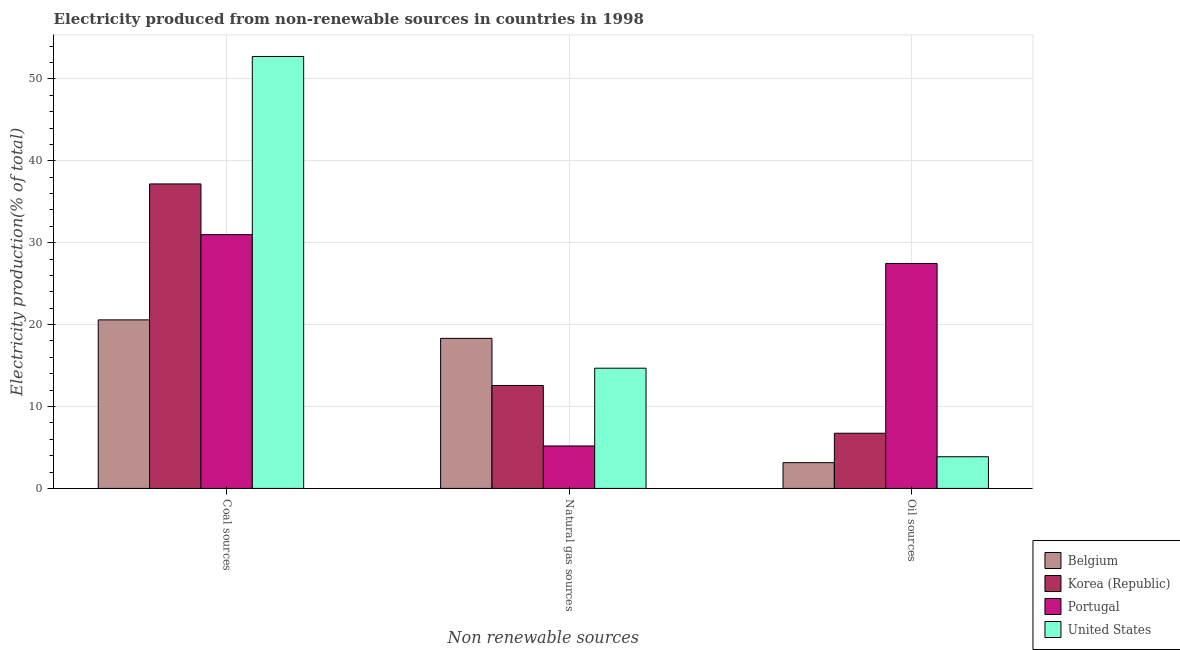How many different coloured bars are there?
Make the answer very short. 4. Are the number of bars on each tick of the X-axis equal?
Offer a very short reply. Yes. What is the label of the 3rd group of bars from the left?
Your answer should be compact. Oil sources. What is the percentage of electricity produced by coal in Belgium?
Ensure brevity in your answer.  20.58. Across all countries, what is the maximum percentage of electricity produced by oil sources?
Give a very brief answer. 27.46. Across all countries, what is the minimum percentage of electricity produced by coal?
Offer a very short reply. 20.58. In which country was the percentage of electricity produced by natural gas minimum?
Make the answer very short. Portugal. What is the total percentage of electricity produced by oil sources in the graph?
Give a very brief answer. 41.21. What is the difference between the percentage of electricity produced by oil sources in Belgium and that in Korea (Republic)?
Ensure brevity in your answer.  -3.59. What is the difference between the percentage of electricity produced by oil sources in Portugal and the percentage of electricity produced by coal in United States?
Keep it short and to the point. -25.27. What is the average percentage of electricity produced by oil sources per country?
Your answer should be compact. 10.3. What is the difference between the percentage of electricity produced by oil sources and percentage of electricity produced by coal in United States?
Ensure brevity in your answer.  -48.87. What is the ratio of the percentage of electricity produced by natural gas in United States to that in Belgium?
Offer a terse response. 0.8. Is the percentage of electricity produced by coal in Portugal less than that in United States?
Provide a short and direct response. Yes. Is the difference between the percentage of electricity produced by coal in Portugal and Korea (Republic) greater than the difference between the percentage of electricity produced by oil sources in Portugal and Korea (Republic)?
Give a very brief answer. No. What is the difference between the highest and the second highest percentage of electricity produced by coal?
Provide a short and direct response. 15.56. What is the difference between the highest and the lowest percentage of electricity produced by coal?
Make the answer very short. 32.16. In how many countries, is the percentage of electricity produced by natural gas greater than the average percentage of electricity produced by natural gas taken over all countries?
Provide a short and direct response. 2. What does the 2nd bar from the left in Natural gas sources represents?
Offer a terse response. Korea (Republic). Is it the case that in every country, the sum of the percentage of electricity produced by coal and percentage of electricity produced by natural gas is greater than the percentage of electricity produced by oil sources?
Provide a short and direct response. Yes. Does the graph contain any zero values?
Provide a short and direct response. No. Does the graph contain grids?
Make the answer very short. Yes. Where does the legend appear in the graph?
Your answer should be compact. Bottom right. How many legend labels are there?
Offer a very short reply. 4. What is the title of the graph?
Make the answer very short. Electricity produced from non-renewable sources in countries in 1998. What is the label or title of the X-axis?
Provide a succinct answer. Non renewable sources. What is the label or title of the Y-axis?
Keep it short and to the point. Electricity production(% of total). What is the Electricity production(% of total) in Belgium in Coal sources?
Your response must be concise. 20.58. What is the Electricity production(% of total) in Korea (Republic) in Coal sources?
Provide a short and direct response. 37.17. What is the Electricity production(% of total) of Portugal in Coal sources?
Offer a terse response. 30.98. What is the Electricity production(% of total) of United States in Coal sources?
Ensure brevity in your answer.  52.74. What is the Electricity production(% of total) of Belgium in Natural gas sources?
Your response must be concise. 18.32. What is the Electricity production(% of total) of Korea (Republic) in Natural gas sources?
Provide a succinct answer. 12.57. What is the Electricity production(% of total) of Portugal in Natural gas sources?
Your response must be concise. 5.19. What is the Electricity production(% of total) of United States in Natural gas sources?
Provide a succinct answer. 14.68. What is the Electricity production(% of total) in Belgium in Oil sources?
Make the answer very short. 3.14. What is the Electricity production(% of total) of Korea (Republic) in Oil sources?
Provide a short and direct response. 6.74. What is the Electricity production(% of total) of Portugal in Oil sources?
Ensure brevity in your answer.  27.46. What is the Electricity production(% of total) of United States in Oil sources?
Offer a terse response. 3.87. Across all Non renewable sources, what is the maximum Electricity production(% of total) of Belgium?
Give a very brief answer. 20.58. Across all Non renewable sources, what is the maximum Electricity production(% of total) in Korea (Republic)?
Make the answer very short. 37.17. Across all Non renewable sources, what is the maximum Electricity production(% of total) of Portugal?
Your response must be concise. 30.98. Across all Non renewable sources, what is the maximum Electricity production(% of total) in United States?
Provide a short and direct response. 52.74. Across all Non renewable sources, what is the minimum Electricity production(% of total) in Belgium?
Ensure brevity in your answer.  3.14. Across all Non renewable sources, what is the minimum Electricity production(% of total) in Korea (Republic)?
Keep it short and to the point. 6.74. Across all Non renewable sources, what is the minimum Electricity production(% of total) in Portugal?
Provide a succinct answer. 5.19. Across all Non renewable sources, what is the minimum Electricity production(% of total) in United States?
Your response must be concise. 3.87. What is the total Electricity production(% of total) in Belgium in the graph?
Provide a succinct answer. 42.04. What is the total Electricity production(% of total) in Korea (Republic) in the graph?
Give a very brief answer. 56.48. What is the total Electricity production(% of total) of Portugal in the graph?
Offer a terse response. 63.63. What is the total Electricity production(% of total) of United States in the graph?
Your response must be concise. 71.28. What is the difference between the Electricity production(% of total) in Belgium in Coal sources and that in Natural gas sources?
Make the answer very short. 2.26. What is the difference between the Electricity production(% of total) of Korea (Republic) in Coal sources and that in Natural gas sources?
Your answer should be compact. 24.61. What is the difference between the Electricity production(% of total) in Portugal in Coal sources and that in Natural gas sources?
Your response must be concise. 25.79. What is the difference between the Electricity production(% of total) in United States in Coal sources and that in Natural gas sources?
Provide a short and direct response. 38.06. What is the difference between the Electricity production(% of total) in Belgium in Coal sources and that in Oil sources?
Make the answer very short. 17.44. What is the difference between the Electricity production(% of total) in Korea (Republic) in Coal sources and that in Oil sources?
Ensure brevity in your answer.  30.44. What is the difference between the Electricity production(% of total) of Portugal in Coal sources and that in Oil sources?
Your answer should be compact. 3.52. What is the difference between the Electricity production(% of total) in United States in Coal sources and that in Oil sources?
Provide a short and direct response. 48.87. What is the difference between the Electricity production(% of total) in Belgium in Natural gas sources and that in Oil sources?
Make the answer very short. 15.18. What is the difference between the Electricity production(% of total) of Korea (Republic) in Natural gas sources and that in Oil sources?
Keep it short and to the point. 5.83. What is the difference between the Electricity production(% of total) in Portugal in Natural gas sources and that in Oil sources?
Give a very brief answer. -22.28. What is the difference between the Electricity production(% of total) of United States in Natural gas sources and that in Oil sources?
Ensure brevity in your answer.  10.81. What is the difference between the Electricity production(% of total) in Belgium in Coal sources and the Electricity production(% of total) in Korea (Republic) in Natural gas sources?
Provide a succinct answer. 8.01. What is the difference between the Electricity production(% of total) in Belgium in Coal sources and the Electricity production(% of total) in Portugal in Natural gas sources?
Give a very brief answer. 15.39. What is the difference between the Electricity production(% of total) in Belgium in Coal sources and the Electricity production(% of total) in United States in Natural gas sources?
Your answer should be compact. 5.9. What is the difference between the Electricity production(% of total) of Korea (Republic) in Coal sources and the Electricity production(% of total) of Portugal in Natural gas sources?
Offer a terse response. 31.99. What is the difference between the Electricity production(% of total) of Korea (Republic) in Coal sources and the Electricity production(% of total) of United States in Natural gas sources?
Provide a succinct answer. 22.5. What is the difference between the Electricity production(% of total) of Portugal in Coal sources and the Electricity production(% of total) of United States in Natural gas sources?
Your answer should be compact. 16.3. What is the difference between the Electricity production(% of total) of Belgium in Coal sources and the Electricity production(% of total) of Korea (Republic) in Oil sources?
Offer a terse response. 13.84. What is the difference between the Electricity production(% of total) of Belgium in Coal sources and the Electricity production(% of total) of Portugal in Oil sources?
Offer a terse response. -6.89. What is the difference between the Electricity production(% of total) in Belgium in Coal sources and the Electricity production(% of total) in United States in Oil sources?
Offer a terse response. 16.71. What is the difference between the Electricity production(% of total) of Korea (Republic) in Coal sources and the Electricity production(% of total) of Portugal in Oil sources?
Give a very brief answer. 9.71. What is the difference between the Electricity production(% of total) of Korea (Republic) in Coal sources and the Electricity production(% of total) of United States in Oil sources?
Give a very brief answer. 33.31. What is the difference between the Electricity production(% of total) in Portugal in Coal sources and the Electricity production(% of total) in United States in Oil sources?
Offer a terse response. 27.11. What is the difference between the Electricity production(% of total) in Belgium in Natural gas sources and the Electricity production(% of total) in Korea (Republic) in Oil sources?
Your response must be concise. 11.58. What is the difference between the Electricity production(% of total) in Belgium in Natural gas sources and the Electricity production(% of total) in Portugal in Oil sources?
Your answer should be very brief. -9.14. What is the difference between the Electricity production(% of total) in Belgium in Natural gas sources and the Electricity production(% of total) in United States in Oil sources?
Ensure brevity in your answer.  14.45. What is the difference between the Electricity production(% of total) of Korea (Republic) in Natural gas sources and the Electricity production(% of total) of Portugal in Oil sources?
Offer a very short reply. -14.9. What is the difference between the Electricity production(% of total) in Korea (Republic) in Natural gas sources and the Electricity production(% of total) in United States in Oil sources?
Make the answer very short. 8.7. What is the difference between the Electricity production(% of total) of Portugal in Natural gas sources and the Electricity production(% of total) of United States in Oil sources?
Provide a succinct answer. 1.32. What is the average Electricity production(% of total) of Belgium per Non renewable sources?
Keep it short and to the point. 14.01. What is the average Electricity production(% of total) of Korea (Republic) per Non renewable sources?
Provide a short and direct response. 18.83. What is the average Electricity production(% of total) in Portugal per Non renewable sources?
Keep it short and to the point. 21.21. What is the average Electricity production(% of total) of United States per Non renewable sources?
Provide a succinct answer. 23.76. What is the difference between the Electricity production(% of total) of Belgium and Electricity production(% of total) of Korea (Republic) in Coal sources?
Your response must be concise. -16.6. What is the difference between the Electricity production(% of total) in Belgium and Electricity production(% of total) in Portugal in Coal sources?
Provide a short and direct response. -10.4. What is the difference between the Electricity production(% of total) in Belgium and Electricity production(% of total) in United States in Coal sources?
Ensure brevity in your answer.  -32.16. What is the difference between the Electricity production(% of total) of Korea (Republic) and Electricity production(% of total) of Portugal in Coal sources?
Offer a very short reply. 6.19. What is the difference between the Electricity production(% of total) of Korea (Republic) and Electricity production(% of total) of United States in Coal sources?
Offer a terse response. -15.56. What is the difference between the Electricity production(% of total) in Portugal and Electricity production(% of total) in United States in Coal sources?
Provide a succinct answer. -21.76. What is the difference between the Electricity production(% of total) of Belgium and Electricity production(% of total) of Korea (Republic) in Natural gas sources?
Provide a succinct answer. 5.75. What is the difference between the Electricity production(% of total) in Belgium and Electricity production(% of total) in Portugal in Natural gas sources?
Provide a succinct answer. 13.13. What is the difference between the Electricity production(% of total) of Belgium and Electricity production(% of total) of United States in Natural gas sources?
Ensure brevity in your answer.  3.64. What is the difference between the Electricity production(% of total) of Korea (Republic) and Electricity production(% of total) of Portugal in Natural gas sources?
Your response must be concise. 7.38. What is the difference between the Electricity production(% of total) in Korea (Republic) and Electricity production(% of total) in United States in Natural gas sources?
Provide a succinct answer. -2.11. What is the difference between the Electricity production(% of total) of Portugal and Electricity production(% of total) of United States in Natural gas sources?
Provide a succinct answer. -9.49. What is the difference between the Electricity production(% of total) in Belgium and Electricity production(% of total) in Korea (Republic) in Oil sources?
Give a very brief answer. -3.59. What is the difference between the Electricity production(% of total) in Belgium and Electricity production(% of total) in Portugal in Oil sources?
Make the answer very short. -24.32. What is the difference between the Electricity production(% of total) in Belgium and Electricity production(% of total) in United States in Oil sources?
Offer a very short reply. -0.72. What is the difference between the Electricity production(% of total) in Korea (Republic) and Electricity production(% of total) in Portugal in Oil sources?
Give a very brief answer. -20.73. What is the difference between the Electricity production(% of total) in Korea (Republic) and Electricity production(% of total) in United States in Oil sources?
Offer a very short reply. 2.87. What is the difference between the Electricity production(% of total) of Portugal and Electricity production(% of total) of United States in Oil sources?
Ensure brevity in your answer.  23.6. What is the ratio of the Electricity production(% of total) in Belgium in Coal sources to that in Natural gas sources?
Your response must be concise. 1.12. What is the ratio of the Electricity production(% of total) in Korea (Republic) in Coal sources to that in Natural gas sources?
Ensure brevity in your answer.  2.96. What is the ratio of the Electricity production(% of total) of Portugal in Coal sources to that in Natural gas sources?
Your answer should be compact. 5.97. What is the ratio of the Electricity production(% of total) of United States in Coal sources to that in Natural gas sources?
Make the answer very short. 3.59. What is the ratio of the Electricity production(% of total) of Belgium in Coal sources to that in Oil sources?
Offer a very short reply. 6.55. What is the ratio of the Electricity production(% of total) in Korea (Republic) in Coal sources to that in Oil sources?
Your response must be concise. 5.52. What is the ratio of the Electricity production(% of total) in Portugal in Coal sources to that in Oil sources?
Offer a very short reply. 1.13. What is the ratio of the Electricity production(% of total) of United States in Coal sources to that in Oil sources?
Offer a very short reply. 13.64. What is the ratio of the Electricity production(% of total) in Belgium in Natural gas sources to that in Oil sources?
Give a very brief answer. 5.83. What is the ratio of the Electricity production(% of total) in Korea (Republic) in Natural gas sources to that in Oil sources?
Your answer should be very brief. 1.87. What is the ratio of the Electricity production(% of total) in Portugal in Natural gas sources to that in Oil sources?
Provide a short and direct response. 0.19. What is the ratio of the Electricity production(% of total) of United States in Natural gas sources to that in Oil sources?
Your answer should be very brief. 3.8. What is the difference between the highest and the second highest Electricity production(% of total) in Belgium?
Make the answer very short. 2.26. What is the difference between the highest and the second highest Electricity production(% of total) of Korea (Republic)?
Keep it short and to the point. 24.61. What is the difference between the highest and the second highest Electricity production(% of total) of Portugal?
Provide a short and direct response. 3.52. What is the difference between the highest and the second highest Electricity production(% of total) of United States?
Offer a very short reply. 38.06. What is the difference between the highest and the lowest Electricity production(% of total) in Belgium?
Your answer should be compact. 17.44. What is the difference between the highest and the lowest Electricity production(% of total) of Korea (Republic)?
Make the answer very short. 30.44. What is the difference between the highest and the lowest Electricity production(% of total) of Portugal?
Your answer should be very brief. 25.79. What is the difference between the highest and the lowest Electricity production(% of total) of United States?
Give a very brief answer. 48.87. 